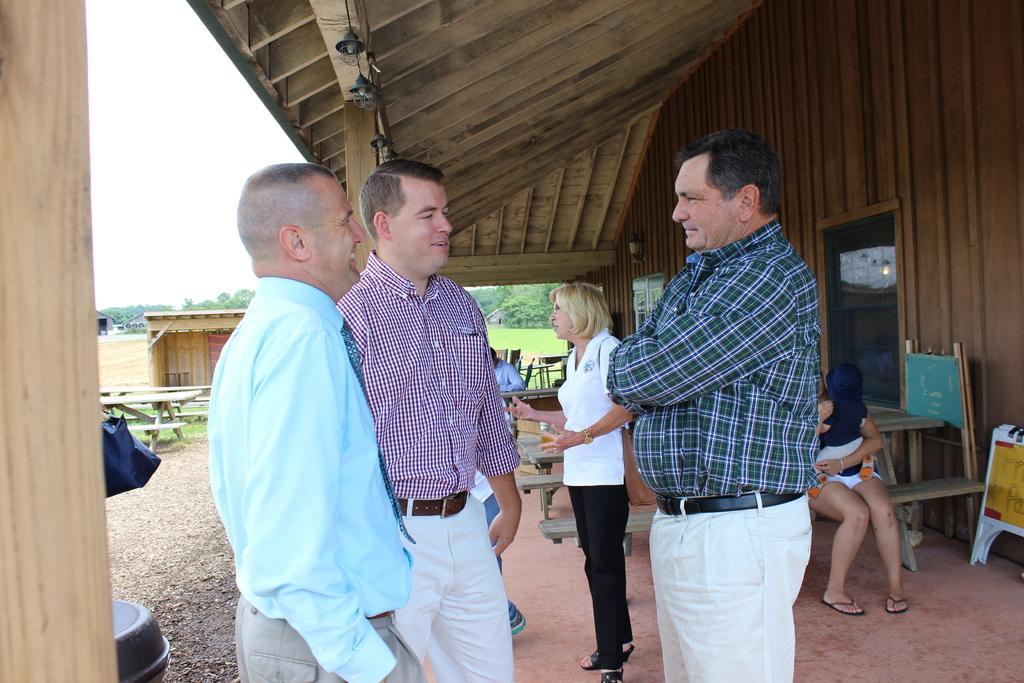Please provide a concise description of this image. In this image there are few persons are standing under the roof of a house. There are few benches. Few persons are sitting on the benches. Right side there is a person holding a baby in his arms. Right side there are few boards. Left side there is a bench on the grassland. Behind there are few houses. Background there are few trees. Left top there is sky. 